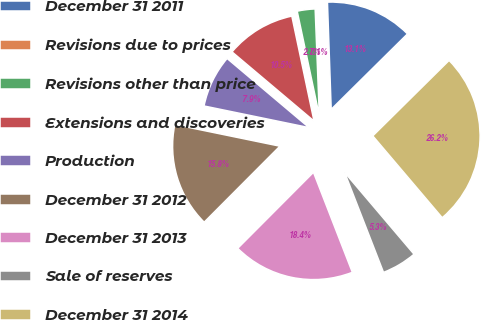Convert chart to OTSL. <chart><loc_0><loc_0><loc_500><loc_500><pie_chart><fcel>December 31 2011<fcel>Revisions due to prices<fcel>Revisions other than price<fcel>Extensions and discoveries<fcel>Production<fcel>December 31 2012<fcel>December 31 2013<fcel>Sale of reserves<fcel>December 31 2014<nl><fcel>13.14%<fcel>0.07%<fcel>2.69%<fcel>10.53%<fcel>7.92%<fcel>15.76%<fcel>18.37%<fcel>5.3%<fcel>26.21%<nl></chart> 